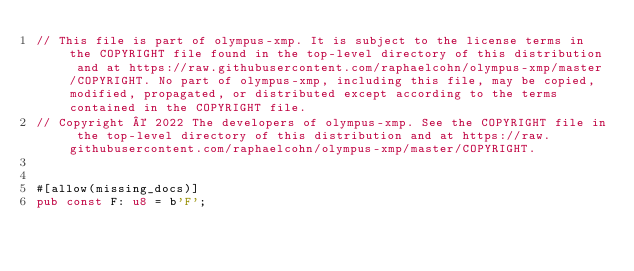Convert code to text. <code><loc_0><loc_0><loc_500><loc_500><_Rust_>// This file is part of olympus-xmp. It is subject to the license terms in the COPYRIGHT file found in the top-level directory of this distribution and at https://raw.githubusercontent.com/raphaelcohn/olympus-xmp/master/COPYRIGHT. No part of olympus-xmp, including this file, may be copied, modified, propagated, or distributed except according to the terms contained in the COPYRIGHT file.
// Copyright © 2022 The developers of olympus-xmp. See the COPYRIGHT file in the top-level directory of this distribution and at https://raw.githubusercontent.com/raphaelcohn/olympus-xmp/master/COPYRIGHT.


#[allow(missing_docs)]
pub const F: u8 = b'F';
</code> 